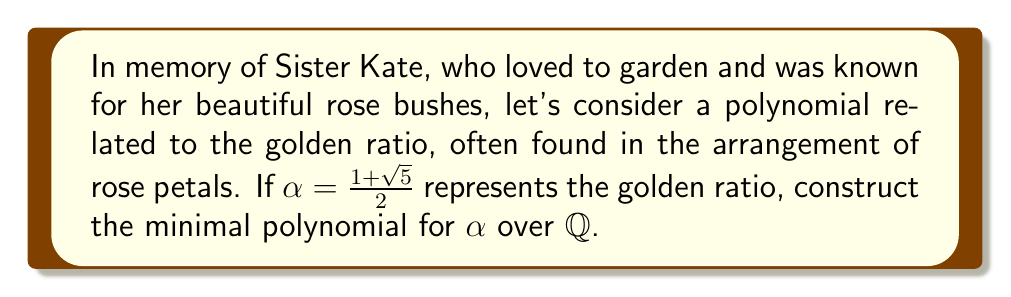What is the answer to this math problem? To construct the minimal polynomial for $\alpha = \frac{1+\sqrt{5}}{2}$ over $\mathbb{Q}$, we'll follow these steps:

1) First, let's set up an equation:
   $x = \frac{1+\sqrt{5}}{2}$

2) Multiply both sides by 2:
   $2x = 1+\sqrt{5}$

3) Subtract 1 from both sides:
   $2x - 1 = \sqrt{5}$

4) Square both sides to eliminate the square root:
   $(2x - 1)^2 = 5$

5) Expand the left side:
   $4x^2 - 4x + 1 = 5$

6) Subtract 5 from both sides:
   $4x^2 - 4x - 4 = 0$

7) Divide everything by 4 to simplify:
   $x^2 - x - 1 = 0$

This quadratic polynomial $x^2 - x - 1$ is monic (leading coefficient is 1) and has $\alpha$ as a root. It's also irreducible over $\mathbb{Q}$ because it has no rational roots (you can check using the rational root theorem). Therefore, it is the minimal polynomial for $\alpha$ over $\mathbb{Q}$.
Answer: $x^2 - x - 1$ 